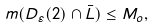Convert formula to latex. <formula><loc_0><loc_0><loc_500><loc_500>m ( D _ { \varepsilon } ( 2 ) \cap \bar { L } ) \leq M _ { o } ,</formula> 